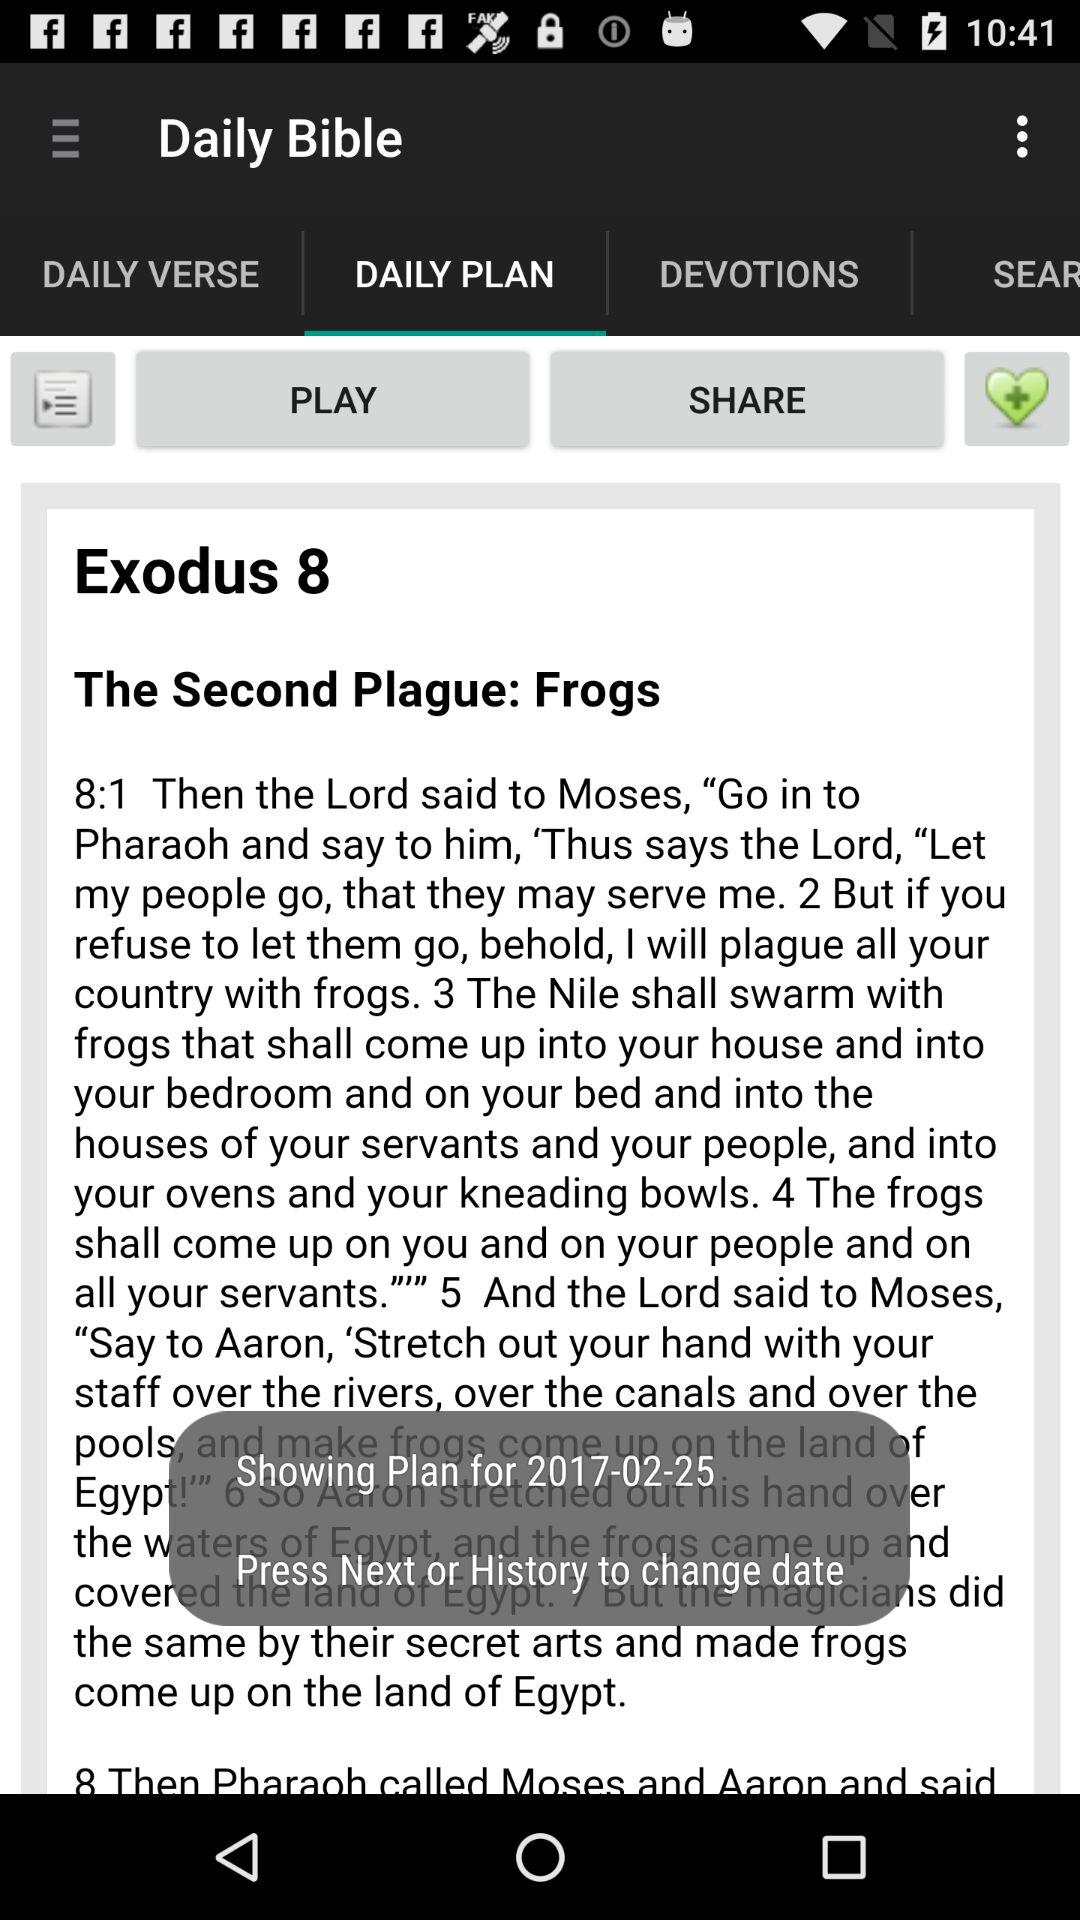Which tab is selected? The selected tab is "DAILY PLAN". 